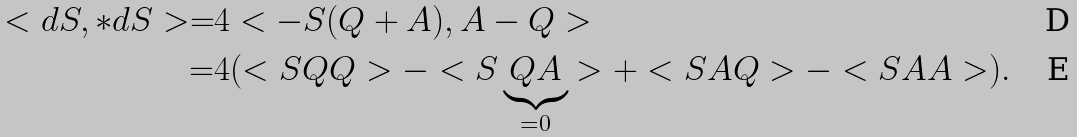Convert formula to latex. <formula><loc_0><loc_0><loc_500><loc_500>< d S , * d S > = & 4 < - S ( Q + A ) , A - Q > \\ = & 4 ( < S Q Q > - < S \underbrace { Q A } _ { = 0 } > + < S A Q > - < S A A > ) .</formula> 